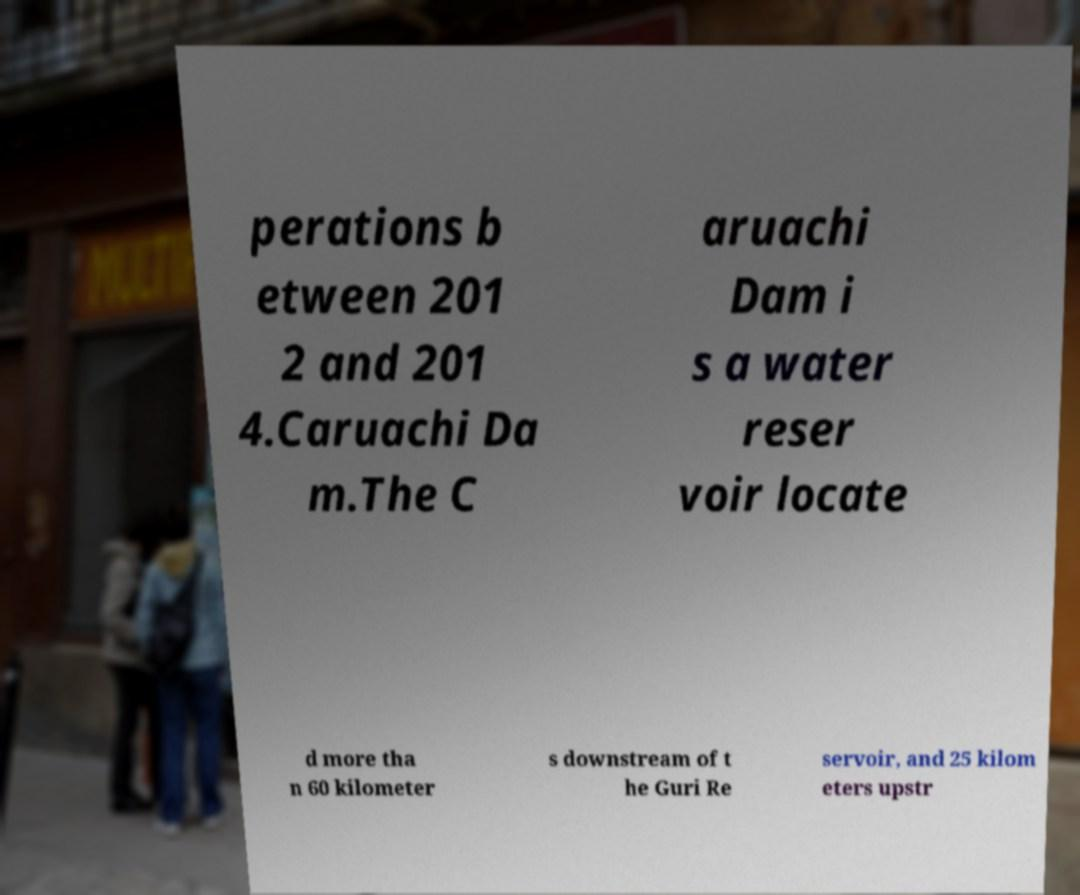There's text embedded in this image that I need extracted. Can you transcribe it verbatim? perations b etween 201 2 and 201 4.Caruachi Da m.The C aruachi Dam i s a water reser voir locate d more tha n 60 kilometer s downstream of t he Guri Re servoir, and 25 kilom eters upstr 